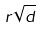<formula> <loc_0><loc_0><loc_500><loc_500>r \sqrt { d }</formula> 